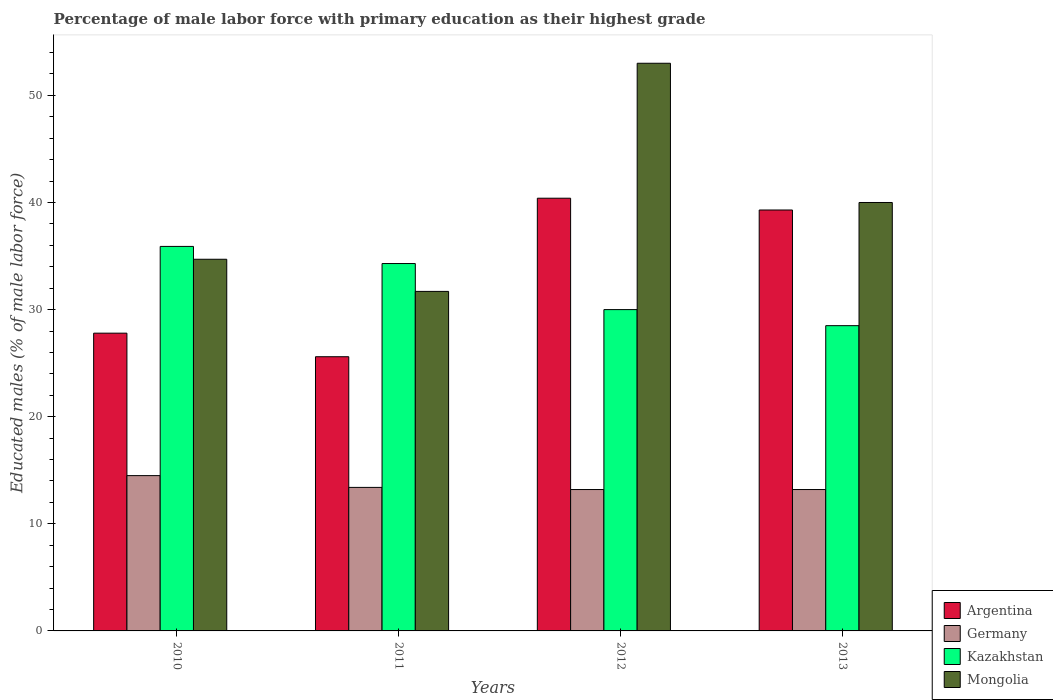Are the number of bars per tick equal to the number of legend labels?
Your response must be concise. Yes. How many bars are there on the 1st tick from the right?
Offer a very short reply. 4. What is the label of the 1st group of bars from the left?
Offer a terse response. 2010. What is the percentage of male labor force with primary education in Argentina in 2012?
Offer a terse response. 40.4. Across all years, what is the maximum percentage of male labor force with primary education in Argentina?
Provide a short and direct response. 40.4. Across all years, what is the minimum percentage of male labor force with primary education in Argentina?
Your answer should be very brief. 25.6. In which year was the percentage of male labor force with primary education in Germany minimum?
Offer a very short reply. 2012. What is the total percentage of male labor force with primary education in Kazakhstan in the graph?
Give a very brief answer. 128.7. What is the difference between the percentage of male labor force with primary education in Argentina in 2010 and that in 2011?
Keep it short and to the point. 2.2. What is the difference between the percentage of male labor force with primary education in Argentina in 2011 and the percentage of male labor force with primary education in Germany in 2010?
Offer a terse response. 11.1. What is the average percentage of male labor force with primary education in Kazakhstan per year?
Provide a succinct answer. 32.18. In the year 2012, what is the difference between the percentage of male labor force with primary education in Argentina and percentage of male labor force with primary education in Kazakhstan?
Your answer should be very brief. 10.4. In how many years, is the percentage of male labor force with primary education in Mongolia greater than 50 %?
Offer a terse response. 1. What is the ratio of the percentage of male labor force with primary education in Mongolia in 2010 to that in 2012?
Your answer should be compact. 0.65. Is the percentage of male labor force with primary education in Mongolia in 2011 less than that in 2012?
Offer a terse response. Yes. What is the difference between the highest and the second highest percentage of male labor force with primary education in Germany?
Offer a very short reply. 1.1. What is the difference between the highest and the lowest percentage of male labor force with primary education in Germany?
Your answer should be very brief. 1.3. In how many years, is the percentage of male labor force with primary education in Kazakhstan greater than the average percentage of male labor force with primary education in Kazakhstan taken over all years?
Your answer should be compact. 2. Is it the case that in every year, the sum of the percentage of male labor force with primary education in Argentina and percentage of male labor force with primary education in Kazakhstan is greater than the sum of percentage of male labor force with primary education in Germany and percentage of male labor force with primary education in Mongolia?
Ensure brevity in your answer.  No. What does the 4th bar from the left in 2012 represents?
Offer a terse response. Mongolia. What does the 4th bar from the right in 2012 represents?
Offer a terse response. Argentina. Is it the case that in every year, the sum of the percentage of male labor force with primary education in Kazakhstan and percentage of male labor force with primary education in Germany is greater than the percentage of male labor force with primary education in Argentina?
Offer a terse response. Yes. How many bars are there?
Provide a short and direct response. 16. Are all the bars in the graph horizontal?
Give a very brief answer. No. What is the difference between two consecutive major ticks on the Y-axis?
Keep it short and to the point. 10. Where does the legend appear in the graph?
Keep it short and to the point. Bottom right. How many legend labels are there?
Your answer should be very brief. 4. How are the legend labels stacked?
Make the answer very short. Vertical. What is the title of the graph?
Provide a short and direct response. Percentage of male labor force with primary education as their highest grade. What is the label or title of the Y-axis?
Offer a terse response. Educated males (% of male labor force). What is the Educated males (% of male labor force) of Argentina in 2010?
Offer a very short reply. 27.8. What is the Educated males (% of male labor force) of Kazakhstan in 2010?
Make the answer very short. 35.9. What is the Educated males (% of male labor force) of Mongolia in 2010?
Your response must be concise. 34.7. What is the Educated males (% of male labor force) in Argentina in 2011?
Provide a short and direct response. 25.6. What is the Educated males (% of male labor force) of Germany in 2011?
Keep it short and to the point. 13.4. What is the Educated males (% of male labor force) of Kazakhstan in 2011?
Provide a short and direct response. 34.3. What is the Educated males (% of male labor force) in Mongolia in 2011?
Offer a terse response. 31.7. What is the Educated males (% of male labor force) in Argentina in 2012?
Your response must be concise. 40.4. What is the Educated males (% of male labor force) in Germany in 2012?
Give a very brief answer. 13.2. What is the Educated males (% of male labor force) of Argentina in 2013?
Provide a short and direct response. 39.3. What is the Educated males (% of male labor force) in Germany in 2013?
Ensure brevity in your answer.  13.2. What is the Educated males (% of male labor force) of Kazakhstan in 2013?
Provide a succinct answer. 28.5. Across all years, what is the maximum Educated males (% of male labor force) in Argentina?
Your response must be concise. 40.4. Across all years, what is the maximum Educated males (% of male labor force) in Kazakhstan?
Offer a terse response. 35.9. Across all years, what is the minimum Educated males (% of male labor force) in Argentina?
Your answer should be compact. 25.6. Across all years, what is the minimum Educated males (% of male labor force) of Germany?
Your answer should be very brief. 13.2. Across all years, what is the minimum Educated males (% of male labor force) in Mongolia?
Offer a terse response. 31.7. What is the total Educated males (% of male labor force) of Argentina in the graph?
Provide a succinct answer. 133.1. What is the total Educated males (% of male labor force) of Germany in the graph?
Provide a short and direct response. 54.3. What is the total Educated males (% of male labor force) of Kazakhstan in the graph?
Provide a succinct answer. 128.7. What is the total Educated males (% of male labor force) of Mongolia in the graph?
Your answer should be compact. 159.4. What is the difference between the Educated males (% of male labor force) of Argentina in 2010 and that in 2011?
Offer a very short reply. 2.2. What is the difference between the Educated males (% of male labor force) of Germany in 2010 and that in 2011?
Offer a very short reply. 1.1. What is the difference between the Educated males (% of male labor force) of Kazakhstan in 2010 and that in 2011?
Provide a succinct answer. 1.6. What is the difference between the Educated males (% of male labor force) of Mongolia in 2010 and that in 2011?
Your response must be concise. 3. What is the difference between the Educated males (% of male labor force) in Germany in 2010 and that in 2012?
Keep it short and to the point. 1.3. What is the difference between the Educated males (% of male labor force) of Mongolia in 2010 and that in 2012?
Your answer should be very brief. -18.3. What is the difference between the Educated males (% of male labor force) in Argentina in 2011 and that in 2012?
Your answer should be very brief. -14.8. What is the difference between the Educated males (% of male labor force) of Germany in 2011 and that in 2012?
Provide a succinct answer. 0.2. What is the difference between the Educated males (% of male labor force) in Kazakhstan in 2011 and that in 2012?
Give a very brief answer. 4.3. What is the difference between the Educated males (% of male labor force) in Mongolia in 2011 and that in 2012?
Offer a very short reply. -21.3. What is the difference between the Educated males (% of male labor force) in Argentina in 2011 and that in 2013?
Your answer should be very brief. -13.7. What is the difference between the Educated males (% of male labor force) in Germany in 2011 and that in 2013?
Offer a very short reply. 0.2. What is the difference between the Educated males (% of male labor force) in Mongolia in 2011 and that in 2013?
Your answer should be compact. -8.3. What is the difference between the Educated males (% of male labor force) in Argentina in 2010 and the Educated males (% of male labor force) in Mongolia in 2011?
Make the answer very short. -3.9. What is the difference between the Educated males (% of male labor force) in Germany in 2010 and the Educated males (% of male labor force) in Kazakhstan in 2011?
Offer a terse response. -19.8. What is the difference between the Educated males (% of male labor force) in Germany in 2010 and the Educated males (% of male labor force) in Mongolia in 2011?
Give a very brief answer. -17.2. What is the difference between the Educated males (% of male labor force) in Kazakhstan in 2010 and the Educated males (% of male labor force) in Mongolia in 2011?
Make the answer very short. 4.2. What is the difference between the Educated males (% of male labor force) in Argentina in 2010 and the Educated males (% of male labor force) in Germany in 2012?
Your answer should be compact. 14.6. What is the difference between the Educated males (% of male labor force) in Argentina in 2010 and the Educated males (% of male labor force) in Mongolia in 2012?
Offer a terse response. -25.2. What is the difference between the Educated males (% of male labor force) in Germany in 2010 and the Educated males (% of male labor force) in Kazakhstan in 2012?
Provide a short and direct response. -15.5. What is the difference between the Educated males (% of male labor force) in Germany in 2010 and the Educated males (% of male labor force) in Mongolia in 2012?
Your answer should be compact. -38.5. What is the difference between the Educated males (% of male labor force) of Kazakhstan in 2010 and the Educated males (% of male labor force) of Mongolia in 2012?
Your answer should be very brief. -17.1. What is the difference between the Educated males (% of male labor force) of Argentina in 2010 and the Educated males (% of male labor force) of Mongolia in 2013?
Your answer should be very brief. -12.2. What is the difference between the Educated males (% of male labor force) in Germany in 2010 and the Educated males (% of male labor force) in Mongolia in 2013?
Offer a very short reply. -25.5. What is the difference between the Educated males (% of male labor force) of Kazakhstan in 2010 and the Educated males (% of male labor force) of Mongolia in 2013?
Make the answer very short. -4.1. What is the difference between the Educated males (% of male labor force) of Argentina in 2011 and the Educated males (% of male labor force) of Kazakhstan in 2012?
Provide a succinct answer. -4.4. What is the difference between the Educated males (% of male labor force) in Argentina in 2011 and the Educated males (% of male labor force) in Mongolia in 2012?
Keep it short and to the point. -27.4. What is the difference between the Educated males (% of male labor force) in Germany in 2011 and the Educated males (% of male labor force) in Kazakhstan in 2012?
Offer a terse response. -16.6. What is the difference between the Educated males (% of male labor force) of Germany in 2011 and the Educated males (% of male labor force) of Mongolia in 2012?
Ensure brevity in your answer.  -39.6. What is the difference between the Educated males (% of male labor force) of Kazakhstan in 2011 and the Educated males (% of male labor force) of Mongolia in 2012?
Offer a terse response. -18.7. What is the difference between the Educated males (% of male labor force) in Argentina in 2011 and the Educated males (% of male labor force) in Germany in 2013?
Make the answer very short. 12.4. What is the difference between the Educated males (% of male labor force) in Argentina in 2011 and the Educated males (% of male labor force) in Kazakhstan in 2013?
Offer a very short reply. -2.9. What is the difference between the Educated males (% of male labor force) in Argentina in 2011 and the Educated males (% of male labor force) in Mongolia in 2013?
Make the answer very short. -14.4. What is the difference between the Educated males (% of male labor force) in Germany in 2011 and the Educated males (% of male labor force) in Kazakhstan in 2013?
Provide a short and direct response. -15.1. What is the difference between the Educated males (% of male labor force) in Germany in 2011 and the Educated males (% of male labor force) in Mongolia in 2013?
Your answer should be compact. -26.6. What is the difference between the Educated males (% of male labor force) of Kazakhstan in 2011 and the Educated males (% of male labor force) of Mongolia in 2013?
Offer a very short reply. -5.7. What is the difference between the Educated males (% of male labor force) in Argentina in 2012 and the Educated males (% of male labor force) in Germany in 2013?
Provide a succinct answer. 27.2. What is the difference between the Educated males (% of male labor force) of Argentina in 2012 and the Educated males (% of male labor force) of Kazakhstan in 2013?
Offer a very short reply. 11.9. What is the difference between the Educated males (% of male labor force) in Argentina in 2012 and the Educated males (% of male labor force) in Mongolia in 2013?
Your response must be concise. 0.4. What is the difference between the Educated males (% of male labor force) in Germany in 2012 and the Educated males (% of male labor force) in Kazakhstan in 2013?
Offer a terse response. -15.3. What is the difference between the Educated males (% of male labor force) of Germany in 2012 and the Educated males (% of male labor force) of Mongolia in 2013?
Offer a terse response. -26.8. What is the average Educated males (% of male labor force) in Argentina per year?
Your response must be concise. 33.27. What is the average Educated males (% of male labor force) of Germany per year?
Provide a succinct answer. 13.57. What is the average Educated males (% of male labor force) in Kazakhstan per year?
Make the answer very short. 32.17. What is the average Educated males (% of male labor force) in Mongolia per year?
Offer a very short reply. 39.85. In the year 2010, what is the difference between the Educated males (% of male labor force) of Argentina and Educated males (% of male labor force) of Kazakhstan?
Provide a short and direct response. -8.1. In the year 2010, what is the difference between the Educated males (% of male labor force) in Germany and Educated males (% of male labor force) in Kazakhstan?
Keep it short and to the point. -21.4. In the year 2010, what is the difference between the Educated males (% of male labor force) in Germany and Educated males (% of male labor force) in Mongolia?
Offer a very short reply. -20.2. In the year 2011, what is the difference between the Educated males (% of male labor force) in Argentina and Educated males (% of male labor force) in Germany?
Offer a very short reply. 12.2. In the year 2011, what is the difference between the Educated males (% of male labor force) in Argentina and Educated males (% of male labor force) in Kazakhstan?
Provide a succinct answer. -8.7. In the year 2011, what is the difference between the Educated males (% of male labor force) of Argentina and Educated males (% of male labor force) of Mongolia?
Keep it short and to the point. -6.1. In the year 2011, what is the difference between the Educated males (% of male labor force) of Germany and Educated males (% of male labor force) of Kazakhstan?
Offer a very short reply. -20.9. In the year 2011, what is the difference between the Educated males (% of male labor force) in Germany and Educated males (% of male labor force) in Mongolia?
Offer a very short reply. -18.3. In the year 2012, what is the difference between the Educated males (% of male labor force) in Argentina and Educated males (% of male labor force) in Germany?
Make the answer very short. 27.2. In the year 2012, what is the difference between the Educated males (% of male labor force) of Argentina and Educated males (% of male labor force) of Mongolia?
Offer a very short reply. -12.6. In the year 2012, what is the difference between the Educated males (% of male labor force) of Germany and Educated males (% of male labor force) of Kazakhstan?
Keep it short and to the point. -16.8. In the year 2012, what is the difference between the Educated males (% of male labor force) of Germany and Educated males (% of male labor force) of Mongolia?
Your response must be concise. -39.8. In the year 2013, what is the difference between the Educated males (% of male labor force) of Argentina and Educated males (% of male labor force) of Germany?
Provide a succinct answer. 26.1. In the year 2013, what is the difference between the Educated males (% of male labor force) of Germany and Educated males (% of male labor force) of Kazakhstan?
Ensure brevity in your answer.  -15.3. In the year 2013, what is the difference between the Educated males (% of male labor force) of Germany and Educated males (% of male labor force) of Mongolia?
Provide a succinct answer. -26.8. What is the ratio of the Educated males (% of male labor force) in Argentina in 2010 to that in 2011?
Make the answer very short. 1.09. What is the ratio of the Educated males (% of male labor force) in Germany in 2010 to that in 2011?
Ensure brevity in your answer.  1.08. What is the ratio of the Educated males (% of male labor force) in Kazakhstan in 2010 to that in 2011?
Your response must be concise. 1.05. What is the ratio of the Educated males (% of male labor force) in Mongolia in 2010 to that in 2011?
Give a very brief answer. 1.09. What is the ratio of the Educated males (% of male labor force) of Argentina in 2010 to that in 2012?
Your answer should be very brief. 0.69. What is the ratio of the Educated males (% of male labor force) of Germany in 2010 to that in 2012?
Keep it short and to the point. 1.1. What is the ratio of the Educated males (% of male labor force) in Kazakhstan in 2010 to that in 2012?
Your response must be concise. 1.2. What is the ratio of the Educated males (% of male labor force) in Mongolia in 2010 to that in 2012?
Provide a short and direct response. 0.65. What is the ratio of the Educated males (% of male labor force) of Argentina in 2010 to that in 2013?
Give a very brief answer. 0.71. What is the ratio of the Educated males (% of male labor force) of Germany in 2010 to that in 2013?
Offer a terse response. 1.1. What is the ratio of the Educated males (% of male labor force) of Kazakhstan in 2010 to that in 2013?
Provide a short and direct response. 1.26. What is the ratio of the Educated males (% of male labor force) in Mongolia in 2010 to that in 2013?
Offer a very short reply. 0.87. What is the ratio of the Educated males (% of male labor force) of Argentina in 2011 to that in 2012?
Offer a terse response. 0.63. What is the ratio of the Educated males (% of male labor force) of Germany in 2011 to that in 2012?
Your answer should be very brief. 1.02. What is the ratio of the Educated males (% of male labor force) in Kazakhstan in 2011 to that in 2012?
Give a very brief answer. 1.14. What is the ratio of the Educated males (% of male labor force) of Mongolia in 2011 to that in 2012?
Give a very brief answer. 0.6. What is the ratio of the Educated males (% of male labor force) of Argentina in 2011 to that in 2013?
Ensure brevity in your answer.  0.65. What is the ratio of the Educated males (% of male labor force) in Germany in 2011 to that in 2013?
Your answer should be very brief. 1.02. What is the ratio of the Educated males (% of male labor force) in Kazakhstan in 2011 to that in 2013?
Your answer should be compact. 1.2. What is the ratio of the Educated males (% of male labor force) in Mongolia in 2011 to that in 2013?
Give a very brief answer. 0.79. What is the ratio of the Educated males (% of male labor force) of Argentina in 2012 to that in 2013?
Your answer should be compact. 1.03. What is the ratio of the Educated males (% of male labor force) of Kazakhstan in 2012 to that in 2013?
Provide a succinct answer. 1.05. What is the ratio of the Educated males (% of male labor force) of Mongolia in 2012 to that in 2013?
Your answer should be compact. 1.32. What is the difference between the highest and the second highest Educated males (% of male labor force) in Kazakhstan?
Your response must be concise. 1.6. What is the difference between the highest and the lowest Educated males (% of male labor force) of Kazakhstan?
Ensure brevity in your answer.  7.4. What is the difference between the highest and the lowest Educated males (% of male labor force) in Mongolia?
Make the answer very short. 21.3. 